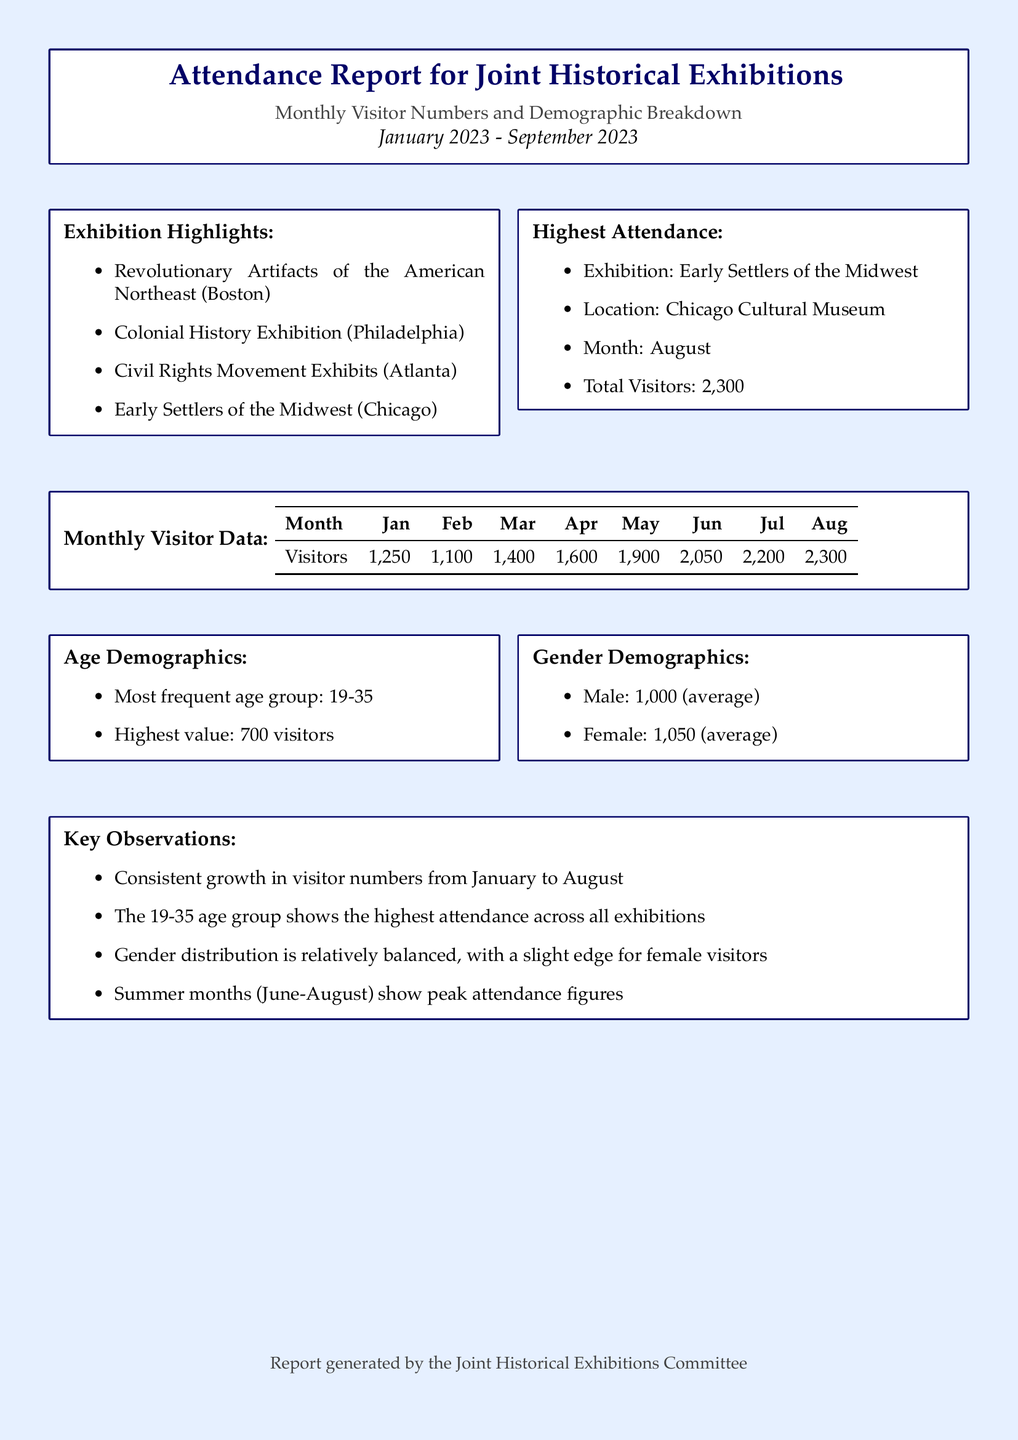What is the average number of male visitors? The average number of male visitors is explicitly stated in the document.
Answer: 1,000 Which exhibition had the highest attendance? The document highlights the exhibition with the most visitors.
Answer: Early Settlers of the Midwest What was the total number of visitors in August? The month of August shows the highest total visitors in the attendance data.
Answer: 2,300 What is the most frequent age group of visitors? The document mentions the age demographic breakdown, stating which group had the most visitors.
Answer: 19-35 Which month had a visitor count of 1,900? The monthly visitor data allows us to pinpoint the number of visitors for each month.
Answer: May What is the gender distribution like in the exhibitions? The document presents average figures for male and female demographics.
Answer: Relatively balanced Which month shows consistent growth in visitor numbers? The report discusses the visitor trends, particularly emphasizing the months with growth.
Answer: January to August What is the highest value for the most frequent age group? The document provides specific numerical data about the most frequent age group's attendance.
Answer: 700 In which city is the exhibition "Revolutionary Artifacts of the American Northeast" located? The exhibition highlights specify the city for this particular exhibition.
Answer: Boston 